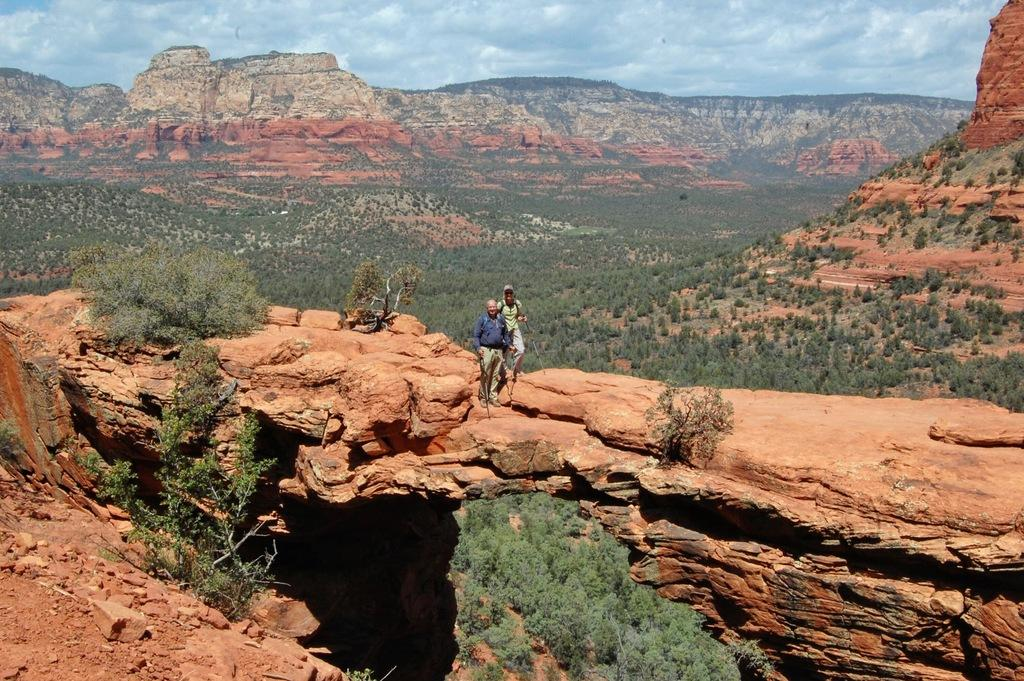How many people are in the image? There are two persons standing on a rock in the image. Where is the rock located in the image? The rock is in the center of the image. What can be seen in the background of the image? There are mountains and trees in the background of the image. Is there a beggar sitting on the rail near the bed in the image? There is no bed, beggar, or rail present in the image. 